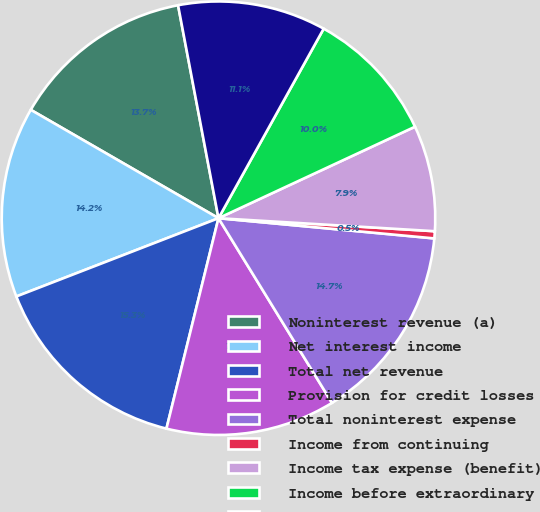<chart> <loc_0><loc_0><loc_500><loc_500><pie_chart><fcel>Noninterest revenue (a)<fcel>Net interest income<fcel>Total net revenue<fcel>Provision for credit losses<fcel>Total noninterest expense<fcel>Income from continuing<fcel>Income tax expense (benefit)<fcel>Income before extraordinary<fcel>Net income<nl><fcel>13.68%<fcel>14.21%<fcel>15.26%<fcel>12.63%<fcel>14.74%<fcel>0.53%<fcel>7.89%<fcel>10.0%<fcel>11.05%<nl></chart> 